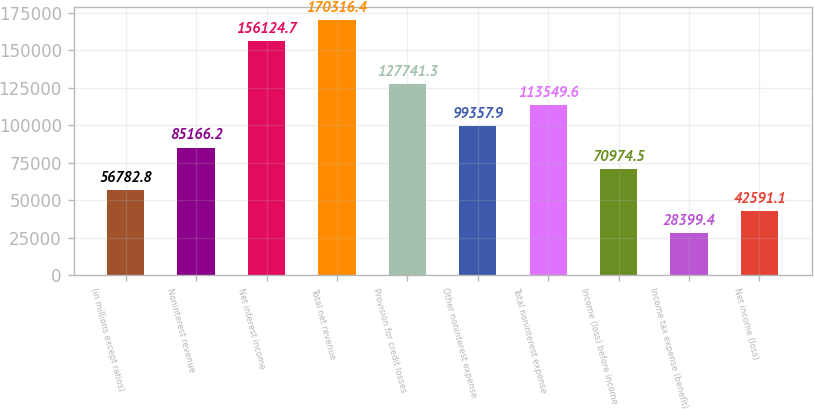<chart> <loc_0><loc_0><loc_500><loc_500><bar_chart><fcel>(in millions except ratios)<fcel>Noninterest revenue<fcel>Net interest income<fcel>Total net revenue<fcel>Provision for credit losses<fcel>Other noninterest expense<fcel>Total noninterest expense<fcel>Income (loss) before income<fcel>Income tax expense (benefit)<fcel>Net income (loss)<nl><fcel>56782.8<fcel>85166.2<fcel>156125<fcel>170316<fcel>127741<fcel>99357.9<fcel>113550<fcel>70974.5<fcel>28399.4<fcel>42591.1<nl></chart> 